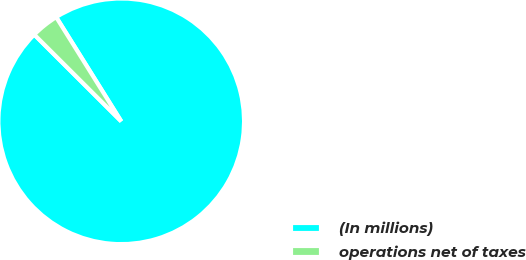Convert chart to OTSL. <chart><loc_0><loc_0><loc_500><loc_500><pie_chart><fcel>(In millions)<fcel>operations net of taxes<nl><fcel>96.36%<fcel>3.64%<nl></chart> 